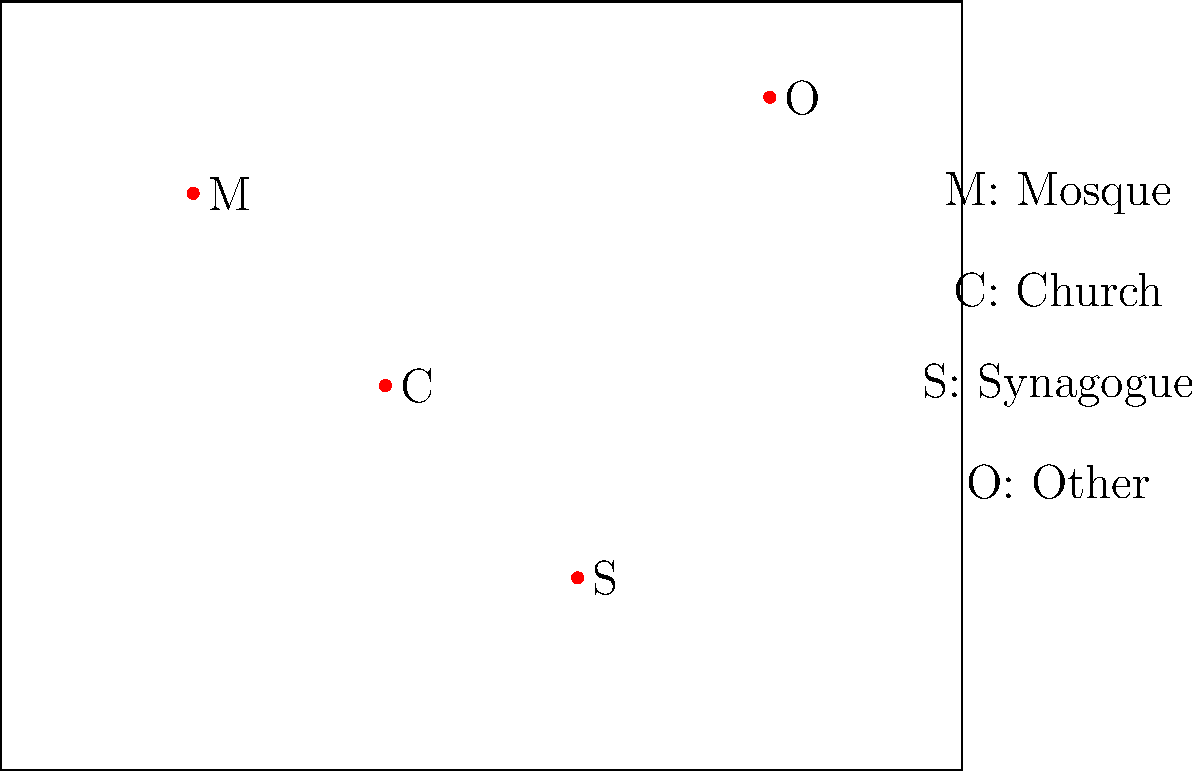Based on the distribution of religious sites shown on the map of Turkey, which type of religious site appears to be located furthest east? To determine which religious site is furthest east, we need to follow these steps:

1. Understand the map orientation: In standard map representations, east is typically to the right of the map.

2. Identify the religious sites:
   M: Mosque
   C: Church
   S: Synagogue
   O: Other

3. Compare the horizontal positions of the sites:
   - The Mosque (M) is in the northwest part of the map.
   - The Church (C) is in the central-west area.
   - The Synagogue (S) is in the southwest region.
   - The Other (O) site is in the northeast part of the map.

4. Determine the easternmost site:
   The site labeled "O" (Other) is positioned furthest to the right on the map, making it the easternmost site.
Answer: Other (O) 